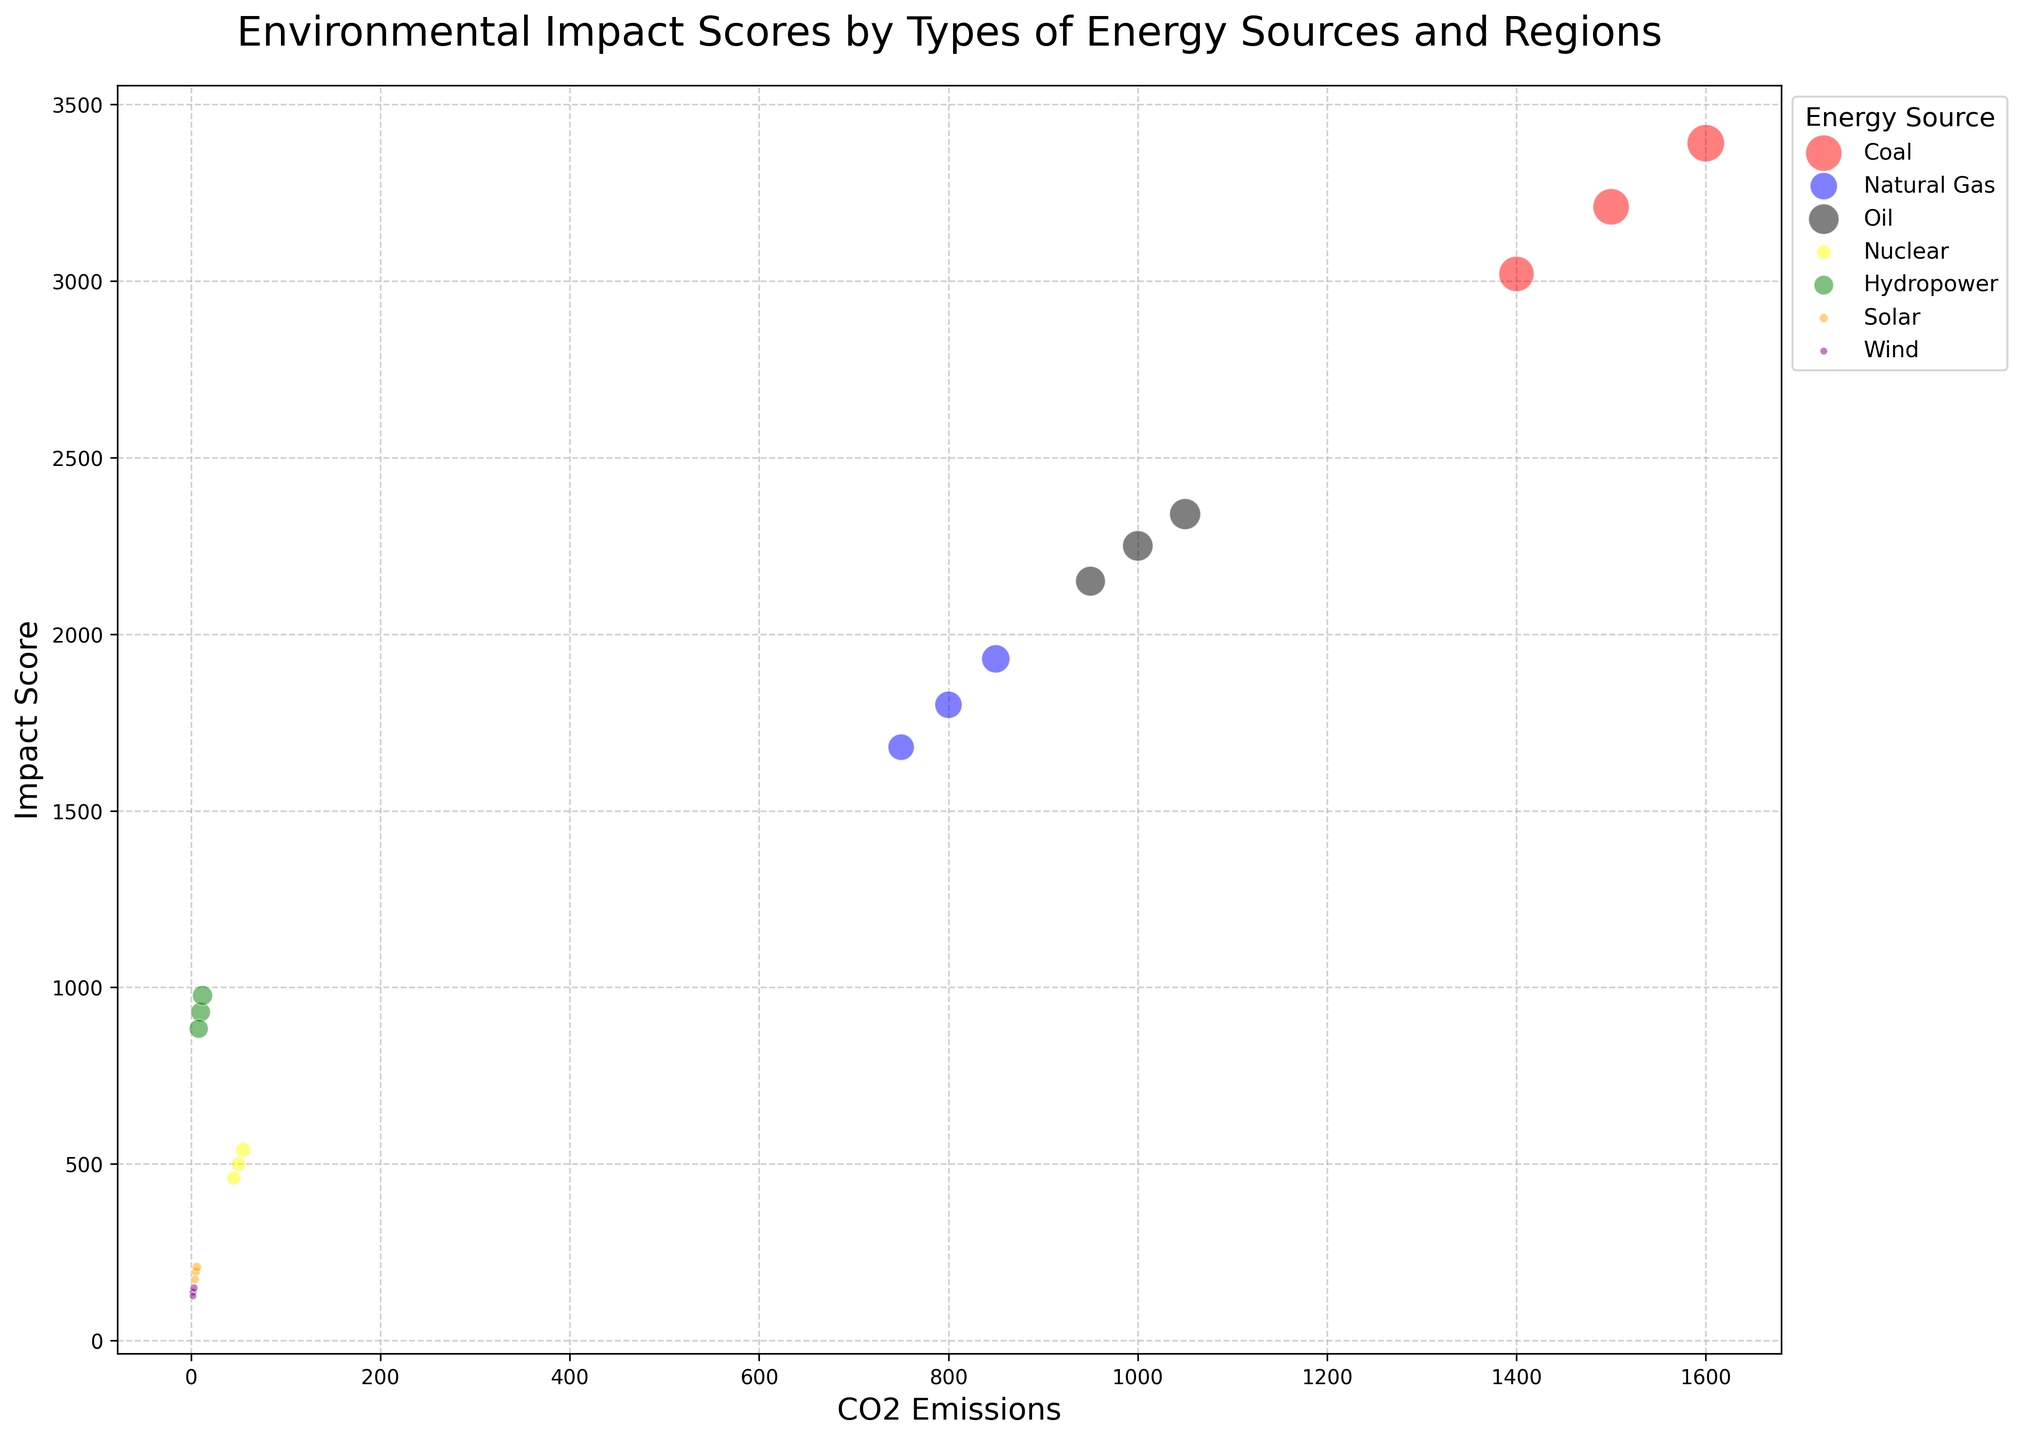What energy source has the highest impact score in Asia? By visually inspecting the size of the bubbles and looking at the labels, the bubble for Coal in Asia is the largest and appears at the highest point on the y-axis, indicating the highest impact score.
Answer: Coal Which energy source has the smallest range of CO2 emissions across all regions? By examining and comparing the horizontal positions of the bubbles for each energy source, the Wind energy source's bubbles are clustered closest together, indicating the smallest range of CO2 emissions.
Answer: Wind Between Nuclear and Hydropower in North America, which has a higher impact score, and by how much? The bubbles for Nuclear and Hydropower in North America can be compared on the y-axis. Hydropower's bubble is higher than Nuclear's, indicating a higher impact score. The difference is 930 - 500 = 430.
Answer: Hydropower, 430 Considering Natural Gas across all regions, what is the average impact score? The impact scores for Natural Gas are 1800, 1680, and 1930. The average is calculated as (1800 + 1680 + 1930) / 3 = 1803.33.
Answer: 1803.33 Which region has the lowest impact score from Solar energy, and what is this score? By looking at the positions of the Solar bubbles along the y-axis for different regions, the bubble in Europe is the lowest, indicating the lowest impact score. The actual score is 173.
Answer: Europe, 173 For Coal and Oil in Europe, which has a higher impact score, and what is their difference? Comparing the vertical positions of the Coal and Oil bubbles in Europe, the Coal bubble is higher. The difference is 3020 - 2150 = 870.
Answer: Coal, 870 Which energy source shows the largest impact score difference between North America and Europe? Evaluate the differences for each energy source: Coal (3210-3020=190), Natural Gas (1800-1680=120), Oil (2250-2150=100), Nuclear (500-460=40), Hydropower (930-883=47), Solar (195-173=22), Wind (137-126=11). The largest is for Coal with a difference of 190.
Answer: Coal If you combine the impact scores from Wind and Solar in Asia, what is their total? The impact scores for Wind and Solar in Asia are 149 and 208, respectively. Therefore, the combined total is 149 + 208 = 357.
Answer: 357 Which energy source exhibits the highest discrepancy in CO2 emissions between North America and Asia? By visually assessing the horizontal spread of bubbles between North America and Asia for each energy source, Coal has the largest difference: 1600 (Asia) - 1500 (North America) = 100.
Answer: Coal 